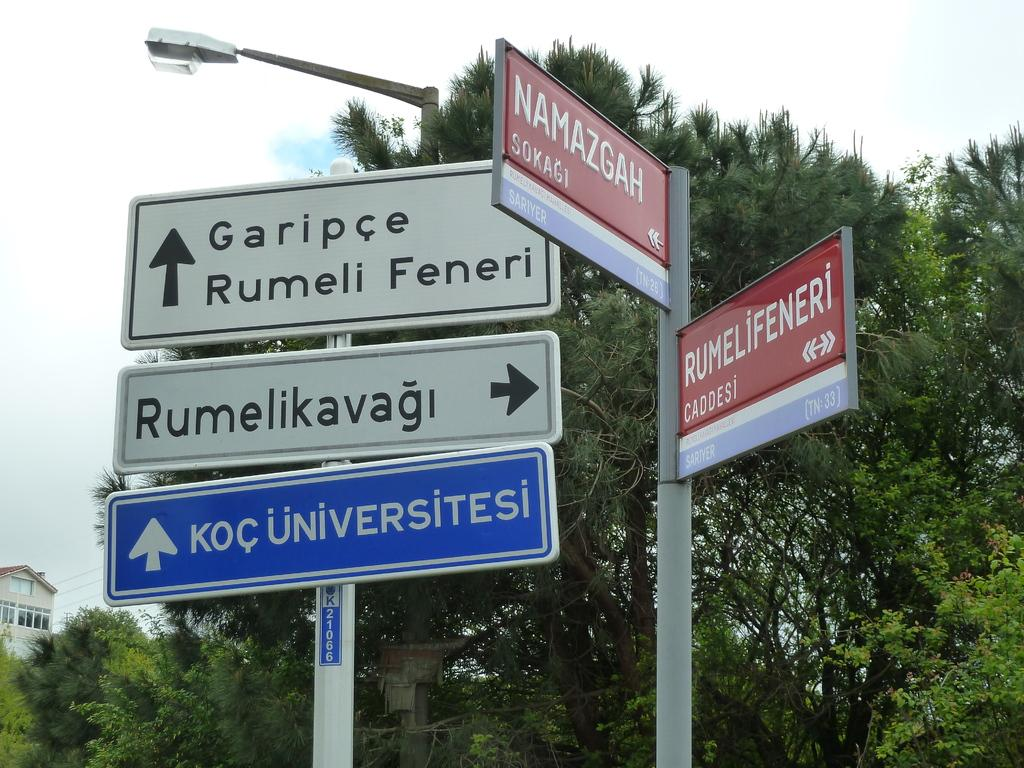<image>
Describe the image concisely. A street sign says Namazgah under a street lamp. 